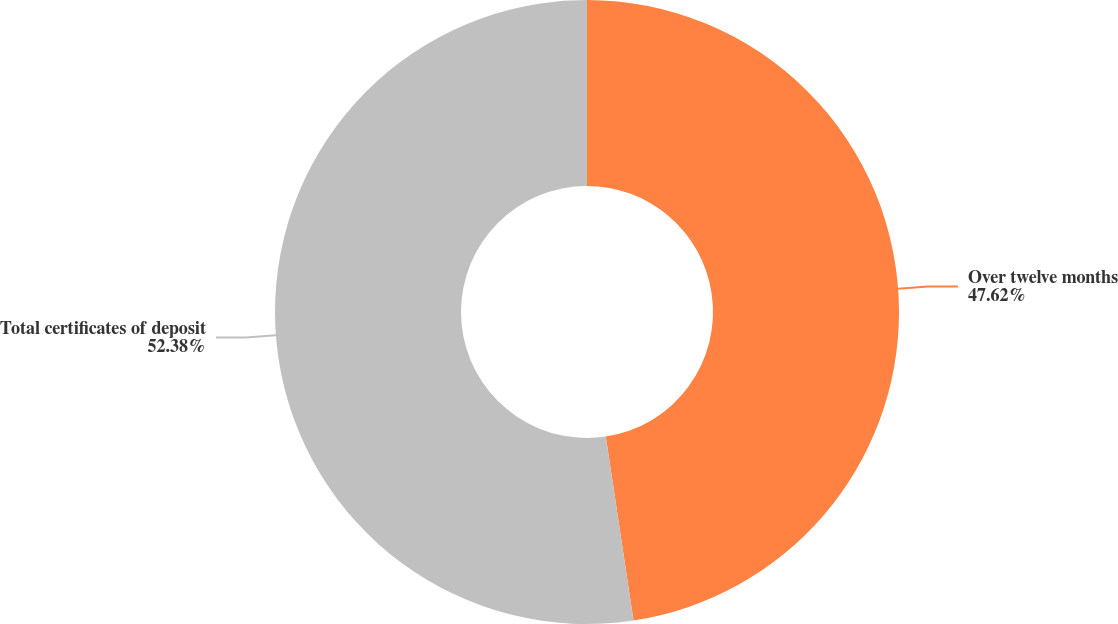Convert chart to OTSL. <chart><loc_0><loc_0><loc_500><loc_500><pie_chart><fcel>Over twelve months<fcel>Total certificates of deposit<nl><fcel>47.62%<fcel>52.38%<nl></chart> 